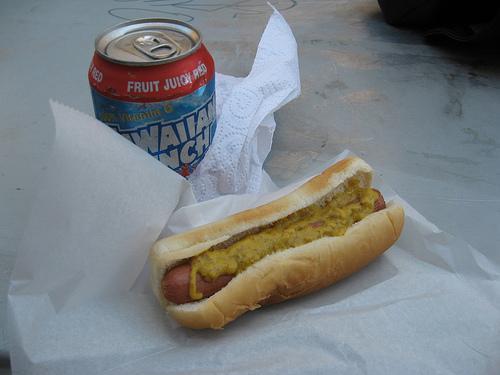How many condiments are on the hot dog?
Give a very brief answer. 1. How many different types of buns do count?
Give a very brief answer. 1. How many hot dogs are there?
Give a very brief answer. 1. 